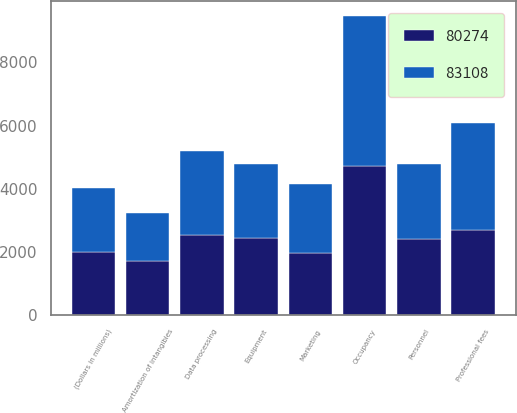Convert chart to OTSL. <chart><loc_0><loc_0><loc_500><loc_500><stacked_bar_chart><ecel><fcel>(Dollars in millions)<fcel>Personnel<fcel>Occupancy<fcel>Equipment<fcel>Marketing<fcel>Professional fees<fcel>Amortization of intangibles<fcel>Data processing<nl><fcel>83108<fcel>2011<fcel>2396<fcel>4748<fcel>2340<fcel>2203<fcel>3381<fcel>1509<fcel>2652<nl><fcel>80274<fcel>2010<fcel>2396<fcel>4716<fcel>2452<fcel>1963<fcel>2695<fcel>1731<fcel>2544<nl></chart> 